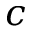<formula> <loc_0><loc_0><loc_500><loc_500>c</formula> 